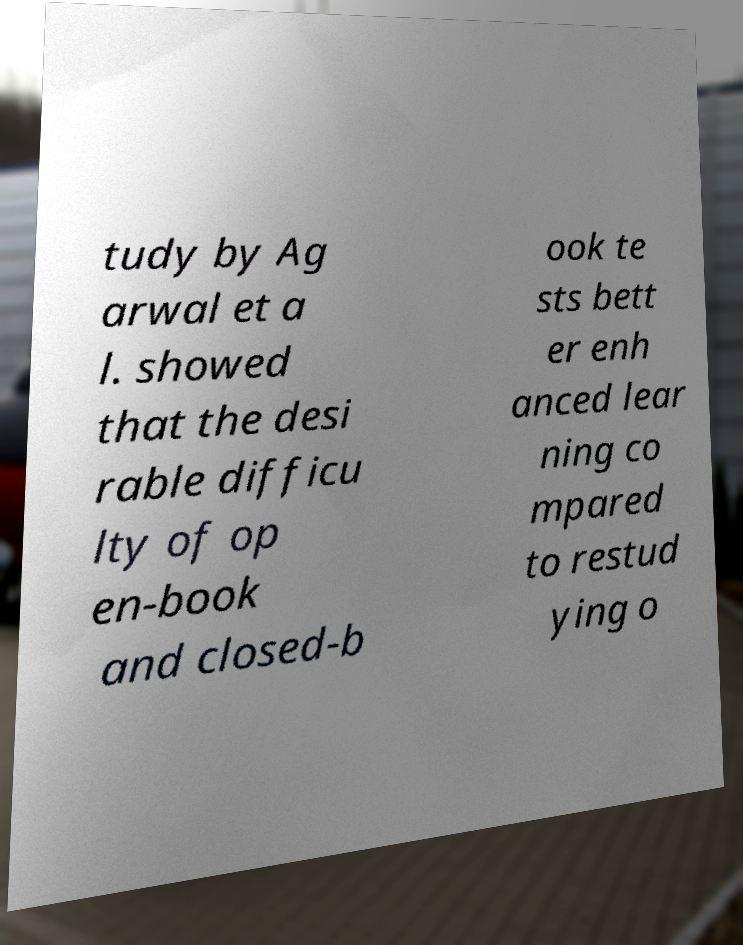Can you read and provide the text displayed in the image?This photo seems to have some interesting text. Can you extract and type it out for me? tudy by Ag arwal et a l. showed that the desi rable difficu lty of op en-book and closed-b ook te sts bett er enh anced lear ning co mpared to restud ying o 